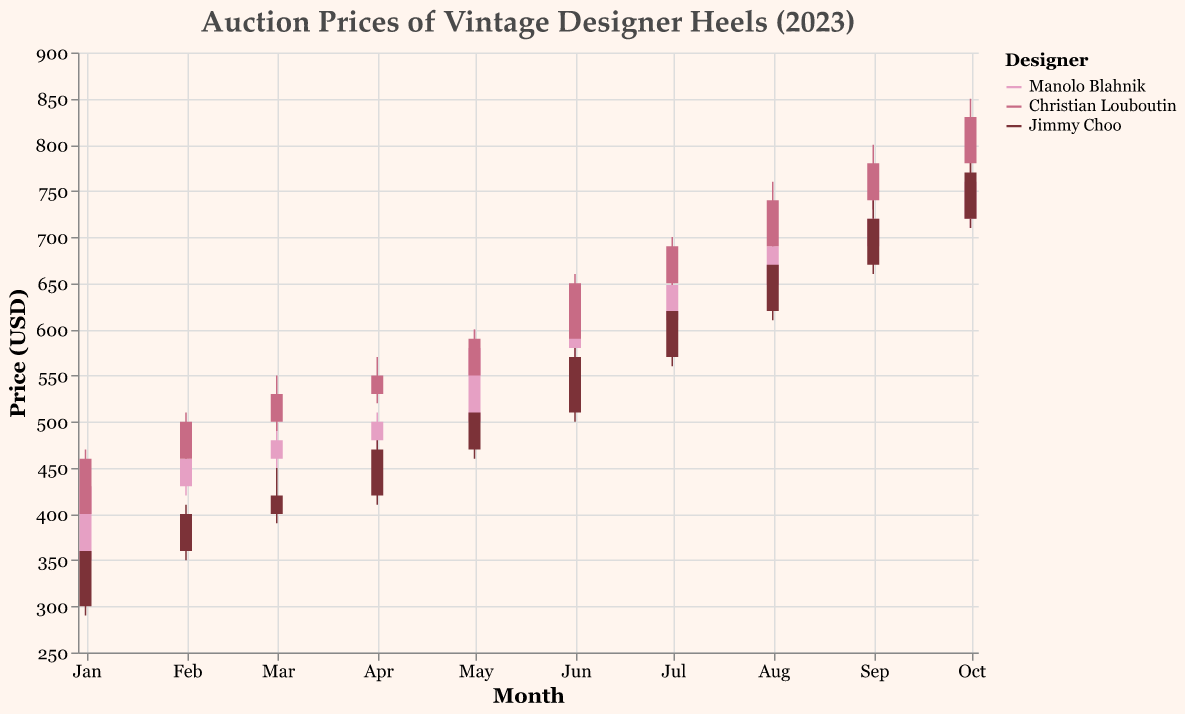What's the highest price reached by Manolo Blahnik heels? The highest price reached by Manolo Blahnik heels over the year can be seen at the peak of the vertical lines in the candlestick plot. The highest value observed is in October, where the high price is 770 USD.
Answer: 770 USD Which month saw the highest closing price for Christian Louboutin heels? To determine the highest closing price, observe the ends of the solid bars for each month in the Christian Louboutin category. The highest closing price is 830 USD in October.
Answer: October What is the overall trend for Jimmy Choo prices from January to October? Observing the positions of the bars and the trend in Jimmy Choo prices, there is an upward trend starting at 360 USD in January and reaching 770 USD in October. The closing prices progressively increase month by month.
Answer: Upward trend Which designer had the steepest increase in prices between January and October? To find the steepest increase, compare the difference between January and October closing prices for each designer. Manolo Blahnik increased from 430 USD to 760 USD (330 USD increase), Christian Louboutin from 460 USD to 830 USD (370 USD increase), and Jimmy Choo from 360 USD to 770 USD (410 USD increase). Hence, Jimmy Choo had the steepest increase of 410 USD.
Answer: Jimmy Choo How do the volatility of Manolo Blahnik prices compare to Christian Louboutin prices in August? Volatility is indicated by the length of the vertical lines, representing the range between high and low prices. In August, Manolo Blahnik's volatility is from 635 to 700 USD (65 USD range), whereas Christian Louboutin's ranges from 680 to 760 USD (80 USD range). Christian Louboutin prices are more volatile.
Answer: Christian Louboutin Which month had the lowest auction price for any of the designers? To find the lowest auction price, identify the lowest points of each vertical line across the three designers. The lowest price is 290 USD for Jimmy Choo in January.
Answer: January Did any designer see a dip in the closing prices between any two consecutive months? Check the closing prices month-by-month for each designer. Jimmy Choo dips from 570 USD to 620 USD in July. Manolo Blahnik dips from 580 USD to 610 USD in June, showing no dips.
Answer: No dips What is the price difference between the highest and lowest closing prices for Christian Louboutin heels over the year? To find the range, subtract the lowest closing price from the highest closing price for Christian Louboutin. The highest closing price is 830 USD in October, and the lowest is 460 USD in January. The difference is 830 - 460 = 370 USD.
Answer: 370 USD Which designer showed the most consistent growth in auction prices? Consistent growth means little volatility and a steady increase in closing prices. Manolo Blahnik and Christian Louboutin both show consistent growth, but Christian Louboutin shows more uniformly increasing prices each month.
Answer: Christian Louboutin 